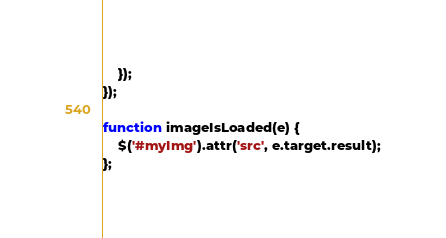<code> <loc_0><loc_0><loc_500><loc_500><_JavaScript_>    });
});

function imageIsLoaded(e) {
    $('#myImg').attr('src', e.target.result);
};
</code> 